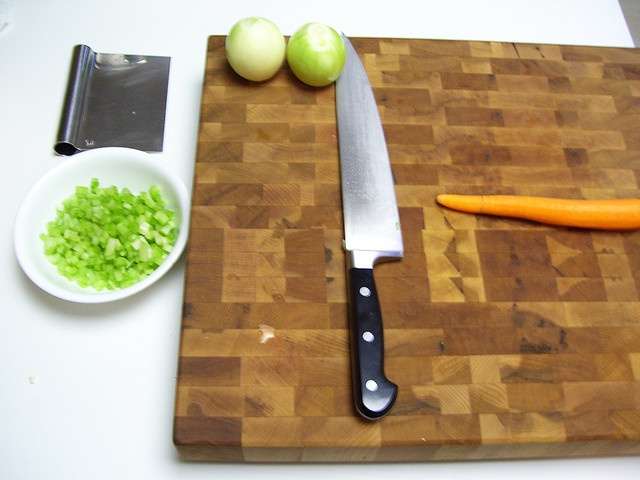Describe the objects in this image and their specific colors. I can see dining table in white, olive, tan, and brown tones, bowl in lightgray, white, lightgreen, and olive tones, knife in lightgray, black, and darkgray tones, carrot in lightgray, orange, red, maroon, and brown tones, and apple in lightgray, lightyellow, olive, and khaki tones in this image. 